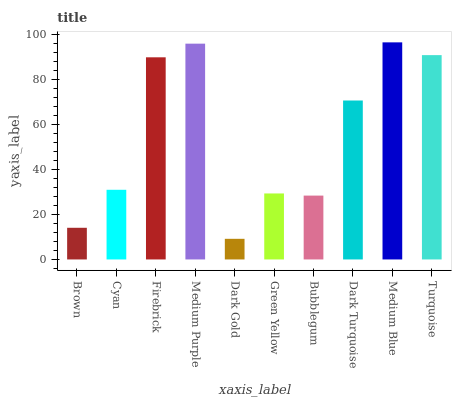Is Dark Gold the minimum?
Answer yes or no. Yes. Is Medium Blue the maximum?
Answer yes or no. Yes. Is Cyan the minimum?
Answer yes or no. No. Is Cyan the maximum?
Answer yes or no. No. Is Cyan greater than Brown?
Answer yes or no. Yes. Is Brown less than Cyan?
Answer yes or no. Yes. Is Brown greater than Cyan?
Answer yes or no. No. Is Cyan less than Brown?
Answer yes or no. No. Is Dark Turquoise the high median?
Answer yes or no. Yes. Is Cyan the low median?
Answer yes or no. Yes. Is Bubblegum the high median?
Answer yes or no. No. Is Firebrick the low median?
Answer yes or no. No. 